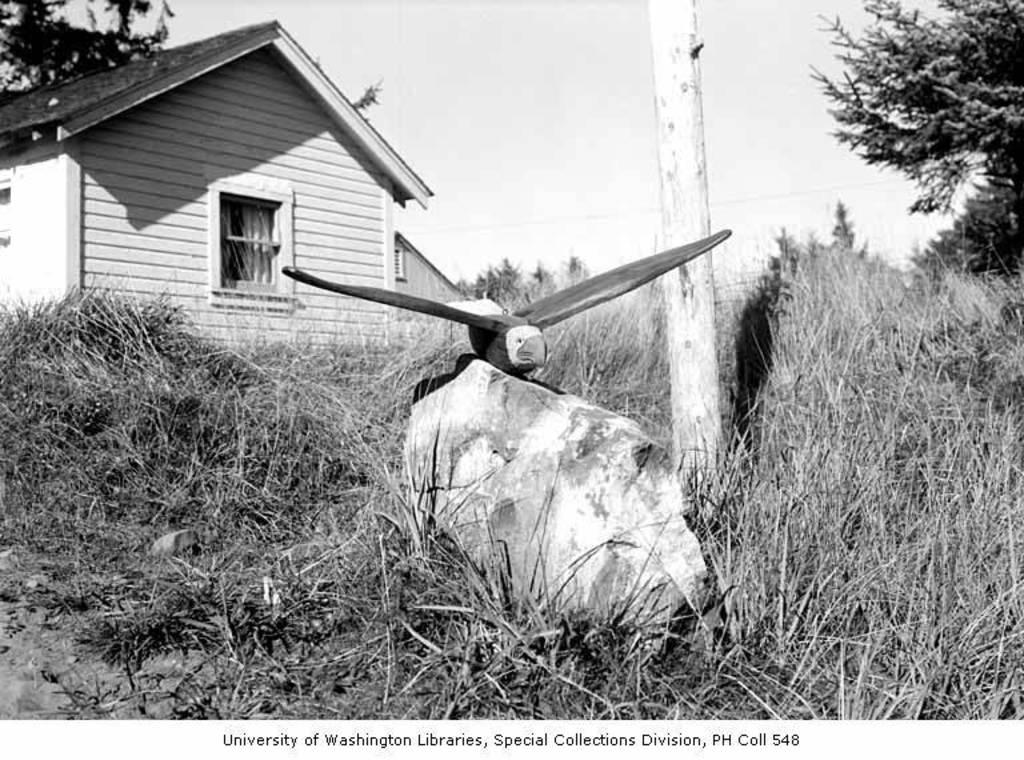<image>
Share a concise interpretation of the image provided. An old photograph  of a house and a wooden eagle from the University of Washington libraries 